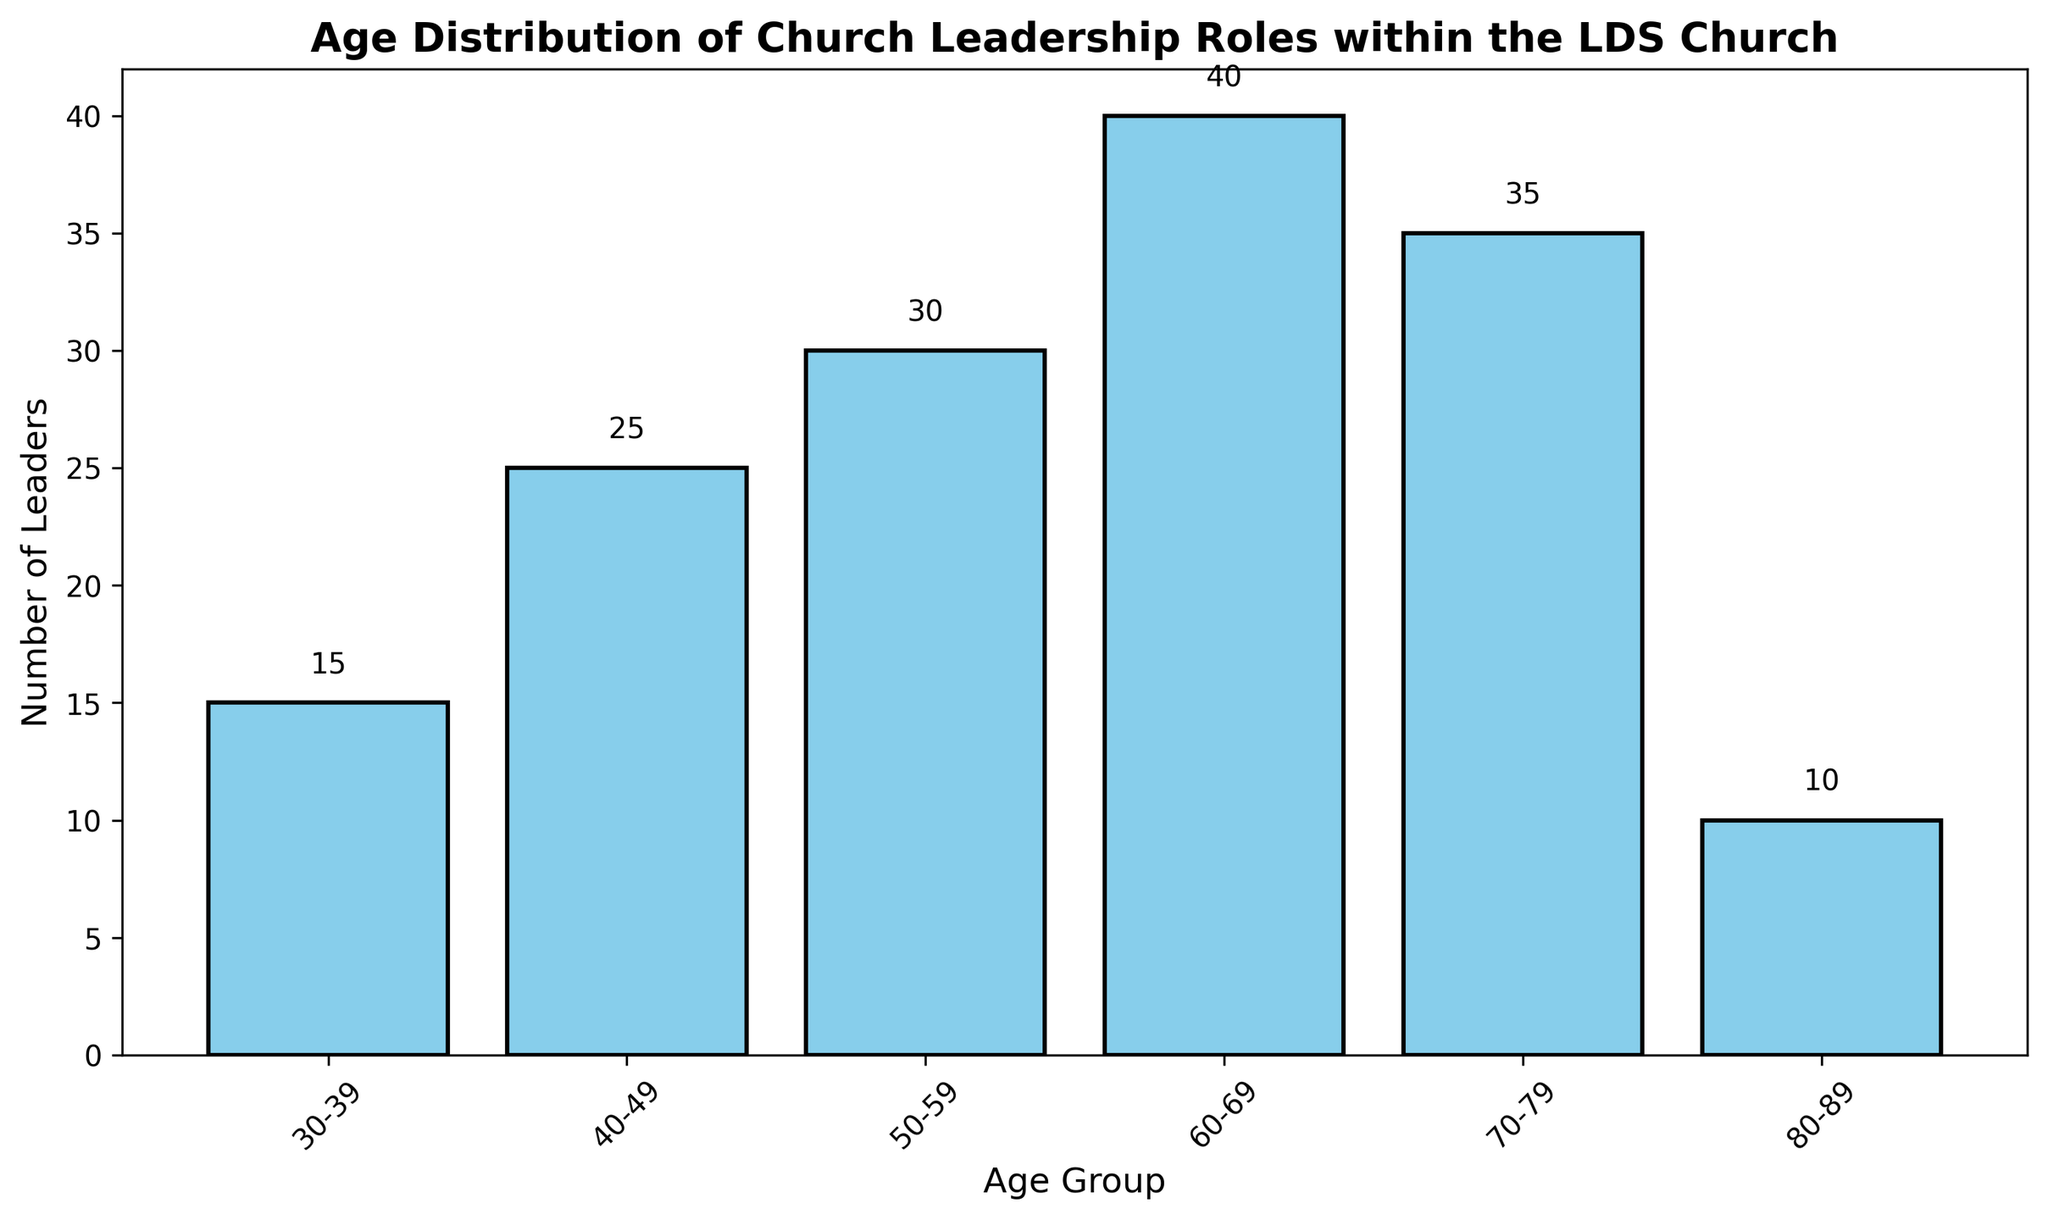What age group has the highest number of church leaders? According to the chart, the age group with the tallest bar represents the highest number of church leaders. The 60-69 age group has the tallest bar, indicating they have the highest number of leaders.
Answer: 60-69 Which two age groups have the smallest difference in the number of church leaders? To find the age groups with the smallest difference, compare the number of leaders across different age groups. The two closest values are 50-59 with 30 leaders and 70-79 with 35 leaders. The difference is 5 leaders.
Answer: 50-59 and 70-79 How many church leaders are older than 50? Add the number of leaders from the 50-59, 60-69, 70-79, and 80-89 age groups. Specifically, 30 + 40 + 35 + 10 = 115.
Answer: 115 What is the sum of church leaders in the 30-39 and 40-49 age groups? Adding the number of leaders in the 30-39 (15) and 40-49 (25) age groups gives: 15 + 25 = 40.
Answer: 40 Are there more church leaders in the 70-79 age group compared to the 50-59 age group? Comparing the bars, the 70-79 age group has 35 leaders while the 50-59 age group has 30 leaders. Therefore, there are more leaders in the 70-79 age group.
Answer: Yes Which age group has the second most church leaders? The age group with the second tallest bar has the second most leaders. The tallest bar is the 60-69 age group, and the second tallest is the 70-79 age group with 35 leaders.
Answer: 70-79 How many more church leaders are in the 60-69 age group compared to the 30-39 age group? Subtract the number of leaders in the 30-39 age group (15) from the 60-69 age group (40). Specifically, 40 - 15 = 25.
Answer: 25 What age group has the fewest church leaders? The age group with the shortest bar has the fewest number of church leaders. The 80-89 age group has the shortest bar, indicating they have the fewest leaders.
Answer: 80-89 What is the total number of church leaders across all age groups? Adding the number of leaders in all age groups: 15 (30-39) + 25 (40-49) + 30 (50-59) + 40 (60-69) + 35 (70-79) + 10 (80-89) = 155.
Answer: 155 